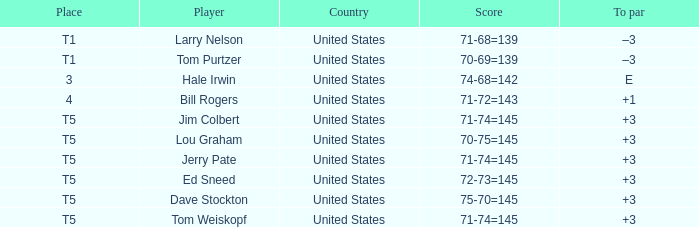What country is player ed sneed, who has a to par of +3, from? United States. 